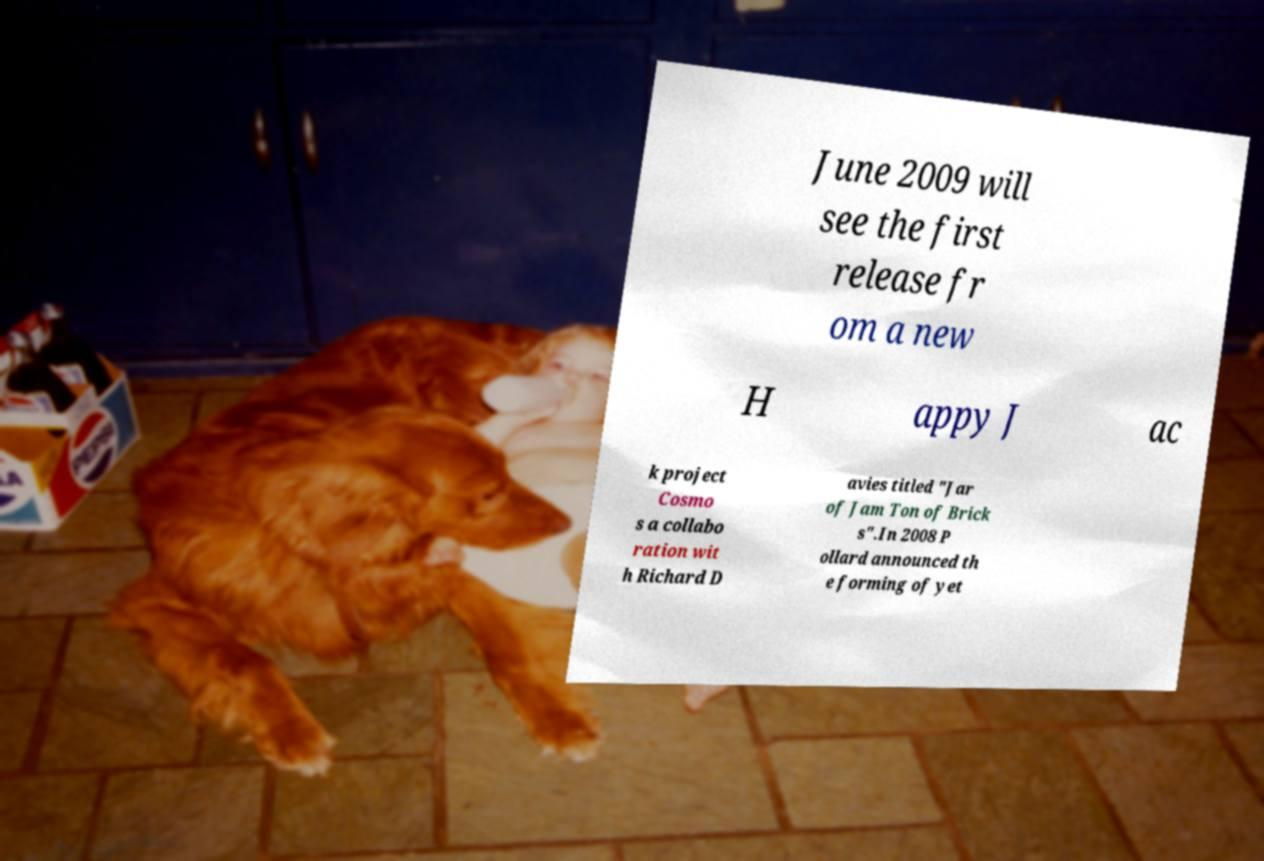Could you assist in decoding the text presented in this image and type it out clearly? June 2009 will see the first release fr om a new H appy J ac k project Cosmo s a collabo ration wit h Richard D avies titled "Jar of Jam Ton of Brick s".In 2008 P ollard announced th e forming of yet 